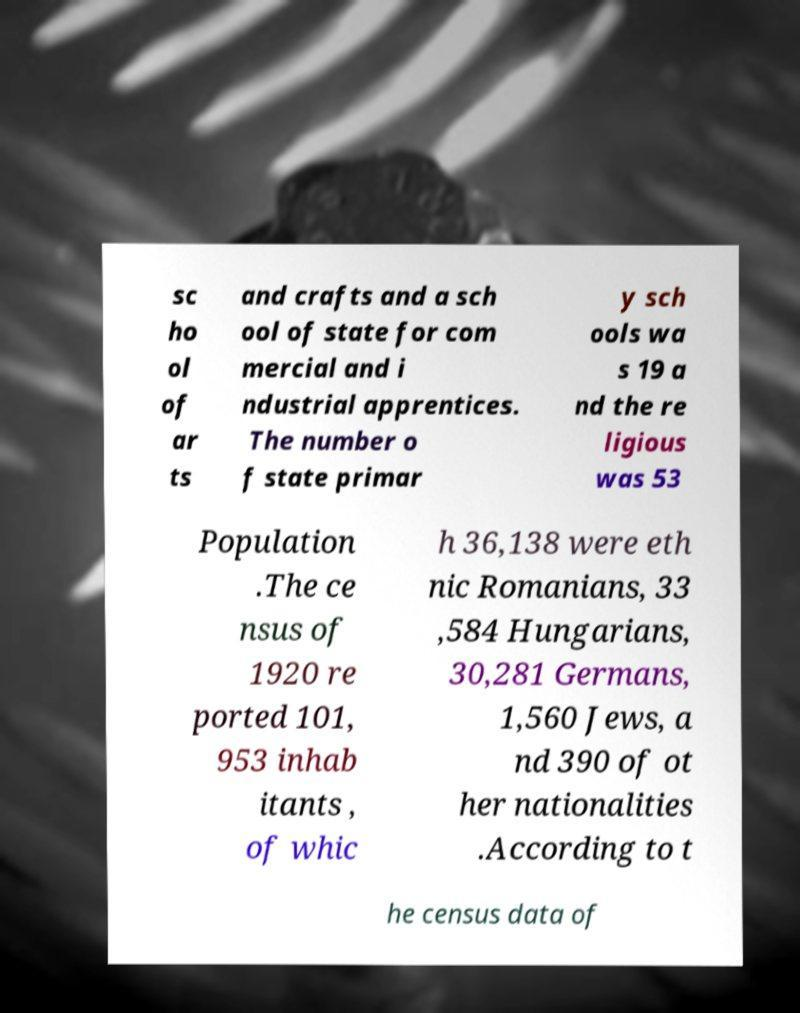Can you accurately transcribe the text from the provided image for me? sc ho ol of ar ts and crafts and a sch ool of state for com mercial and i ndustrial apprentices. The number o f state primar y sch ools wa s 19 a nd the re ligious was 53 Population .The ce nsus of 1920 re ported 101, 953 inhab itants , of whic h 36,138 were eth nic Romanians, 33 ,584 Hungarians, 30,281 Germans, 1,560 Jews, a nd 390 of ot her nationalities .According to t he census data of 